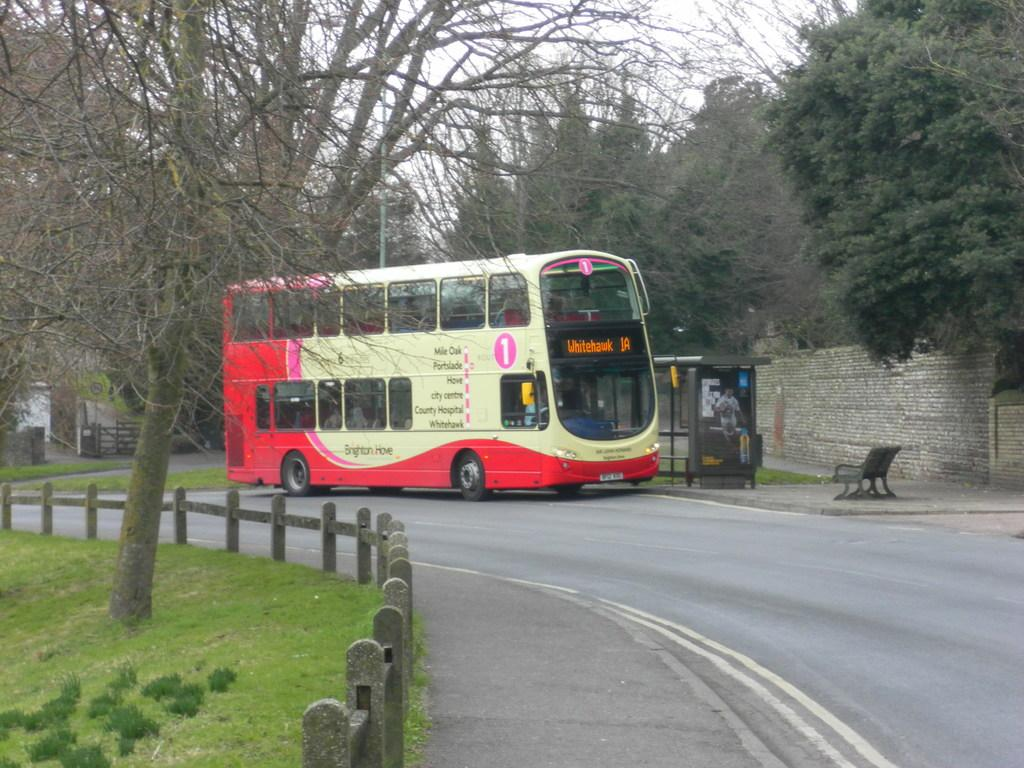What is the main subject of the image? The main subject of the image is a bus. Where is the bus located in the image? The bus is on the road in the image. What can be seen on the left side of the image? There is a small garden with a dry tree on the left side of the image. What is visible behind a wall in the image? There are many trees behind a wall in the image. What color is the paint on the frogs in the image? There are no frogs present in the image, and therefore no paint on them. 